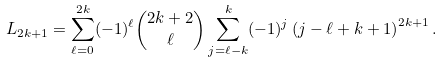<formula> <loc_0><loc_0><loc_500><loc_500>L _ { 2 k + 1 } = \sum _ { \ell = 0 } ^ { 2 k } ( - 1 ) ^ { \ell } \binom { 2 k + 2 } { \ell } \sum _ { j = \ell - k } ^ { k } ( - 1 ) ^ { j } \left ( j - \ell + k + 1 \right ) ^ { 2 k + 1 } .</formula> 